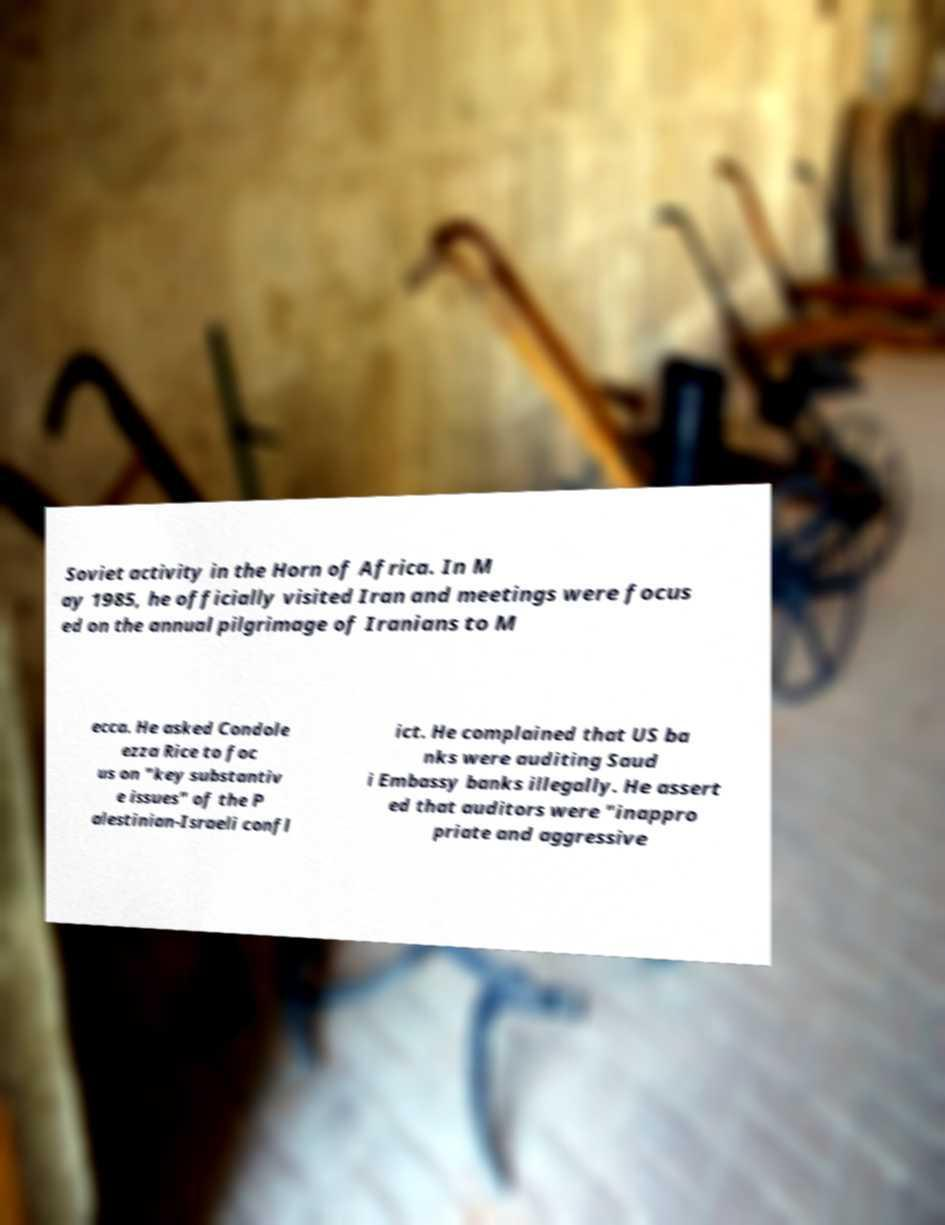Can you read and provide the text displayed in the image?This photo seems to have some interesting text. Can you extract and type it out for me? Soviet activity in the Horn of Africa. In M ay 1985, he officially visited Iran and meetings were focus ed on the annual pilgrimage of Iranians to M ecca. He asked Condole ezza Rice to foc us on "key substantiv e issues" of the P alestinian-Israeli confl ict. He complained that US ba nks were auditing Saud i Embassy banks illegally. He assert ed that auditors were "inappro priate and aggressive 